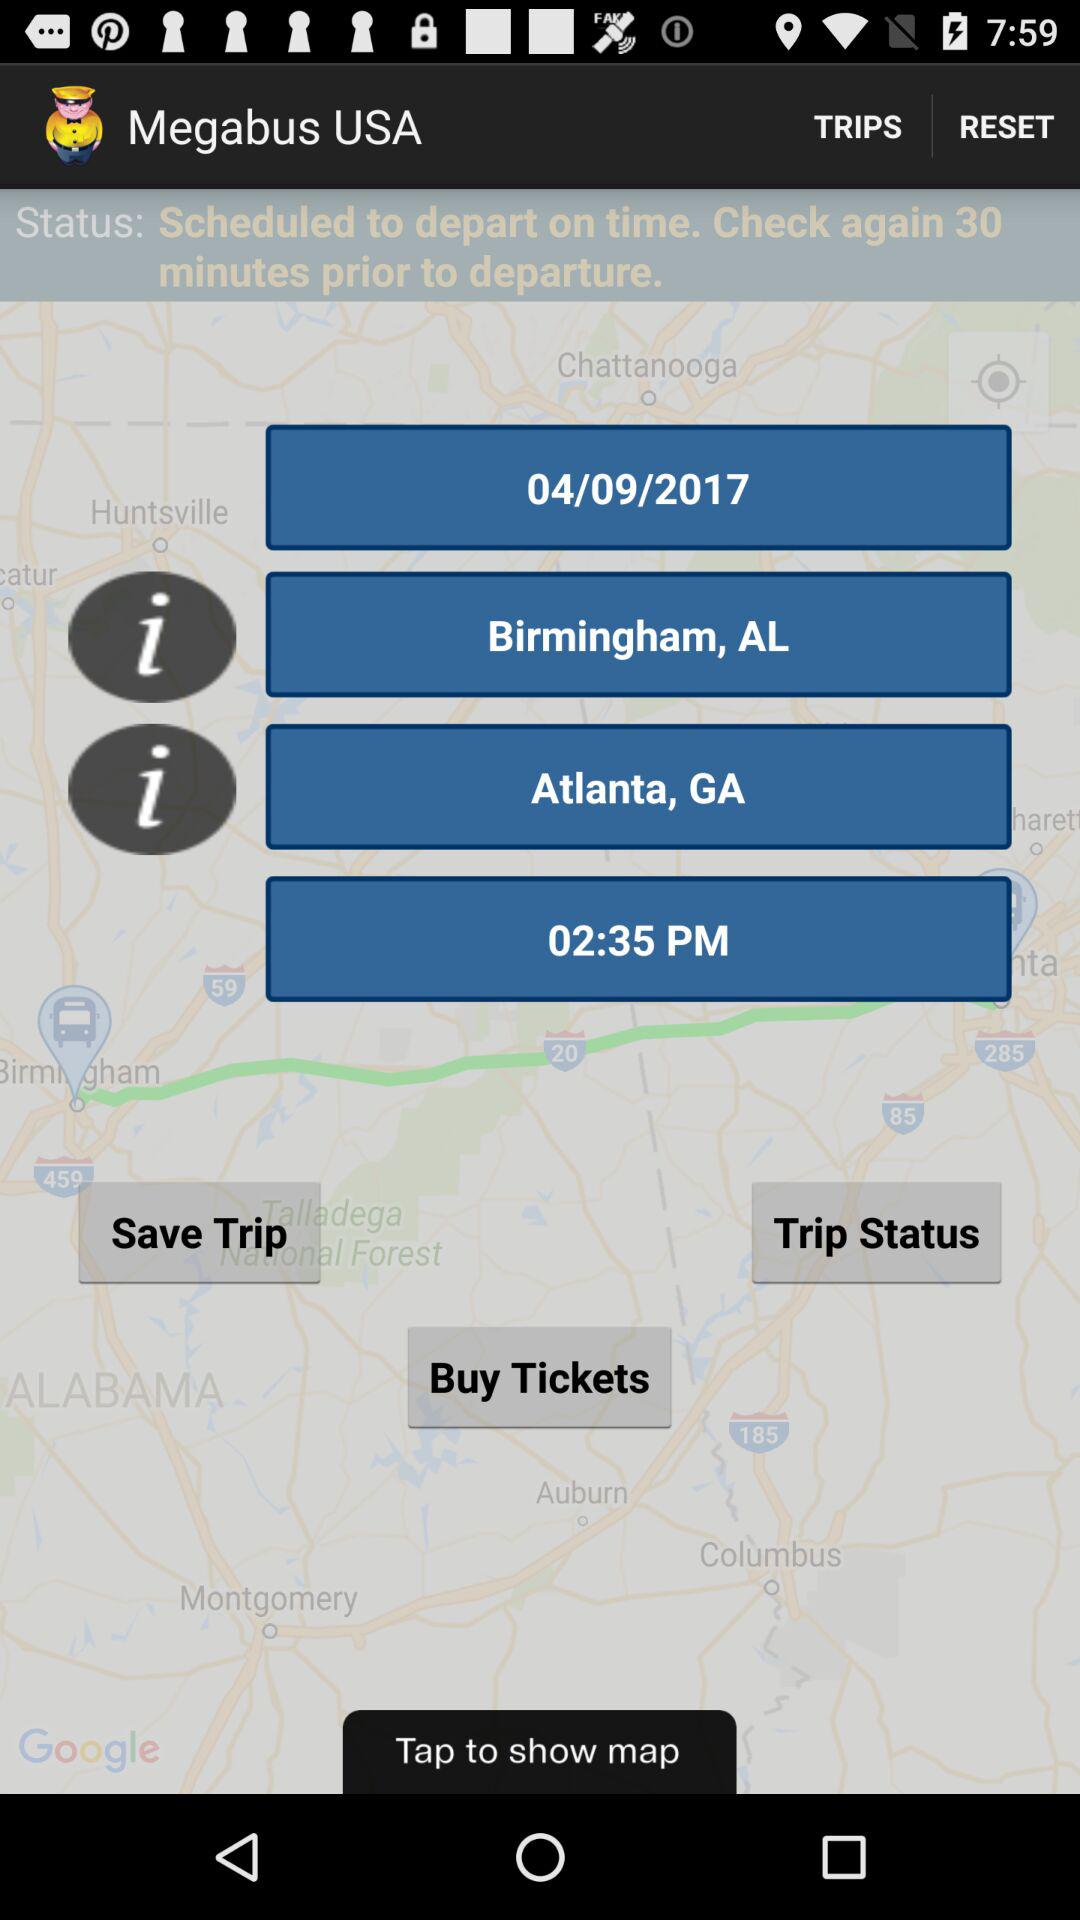What's the location? The locations are Birmingham, AL and Atlanta, GA. 